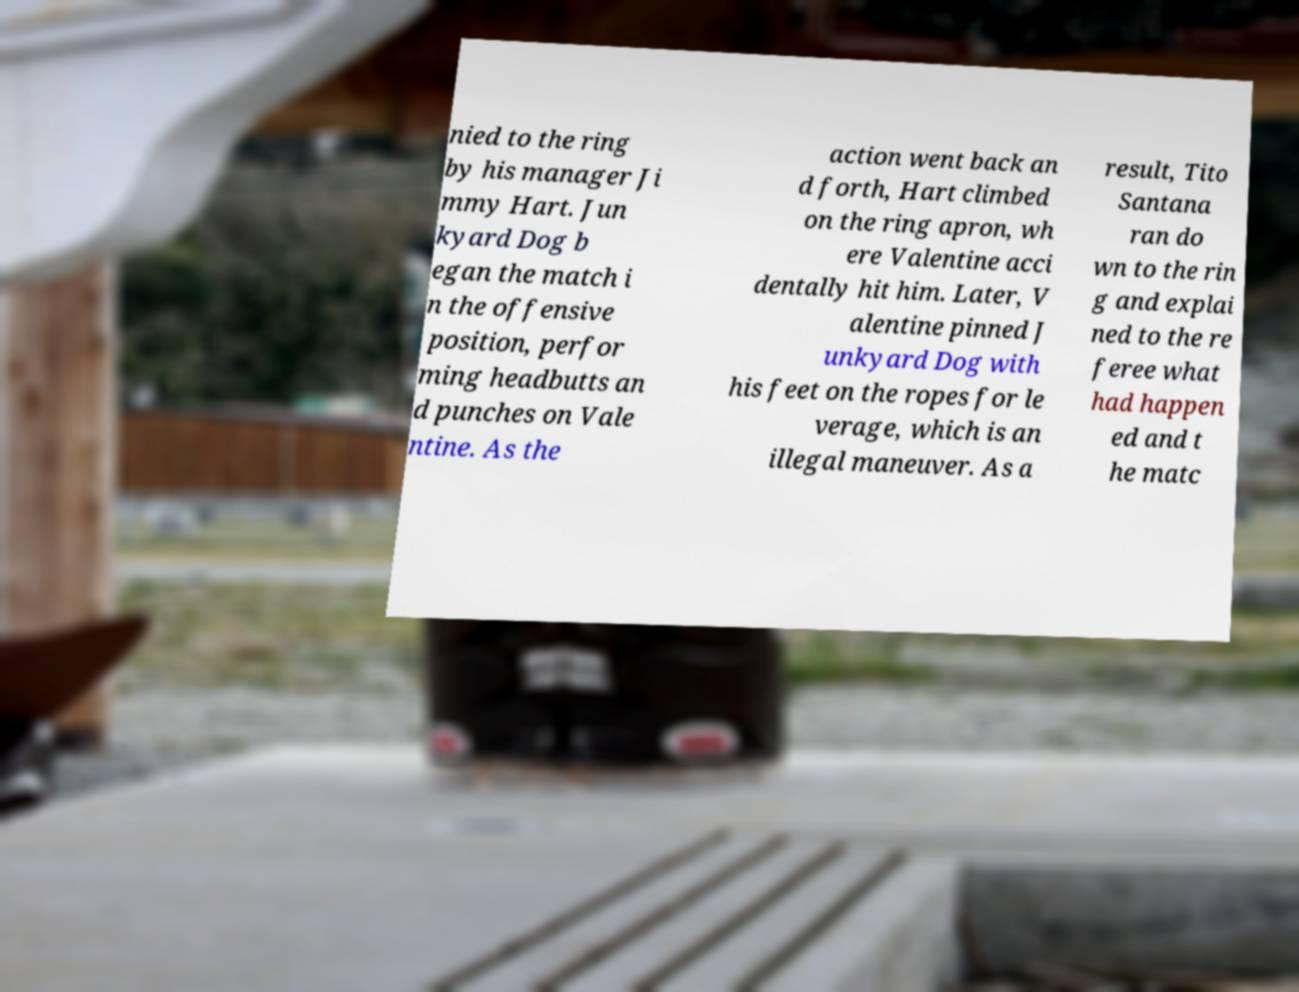For documentation purposes, I need the text within this image transcribed. Could you provide that? nied to the ring by his manager Ji mmy Hart. Jun kyard Dog b egan the match i n the offensive position, perfor ming headbutts an d punches on Vale ntine. As the action went back an d forth, Hart climbed on the ring apron, wh ere Valentine acci dentally hit him. Later, V alentine pinned J unkyard Dog with his feet on the ropes for le verage, which is an illegal maneuver. As a result, Tito Santana ran do wn to the rin g and explai ned to the re feree what had happen ed and t he matc 